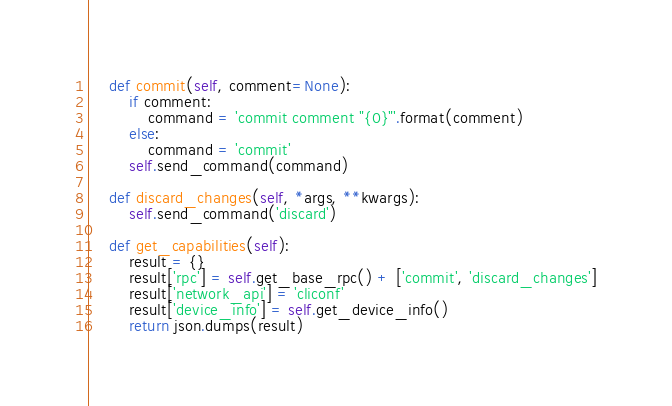<code> <loc_0><loc_0><loc_500><loc_500><_Python_>
    def commit(self, comment=None):
        if comment:
            command = 'commit comment "{0}"'.format(comment)
        else:
            command = 'commit'
        self.send_command(command)

    def discard_changes(self, *args, **kwargs):
        self.send_command('discard')

    def get_capabilities(self):
        result = {}
        result['rpc'] = self.get_base_rpc() + ['commit', 'discard_changes']
        result['network_api'] = 'cliconf'
        result['device_info'] = self.get_device_info()
        return json.dumps(result)
</code> 